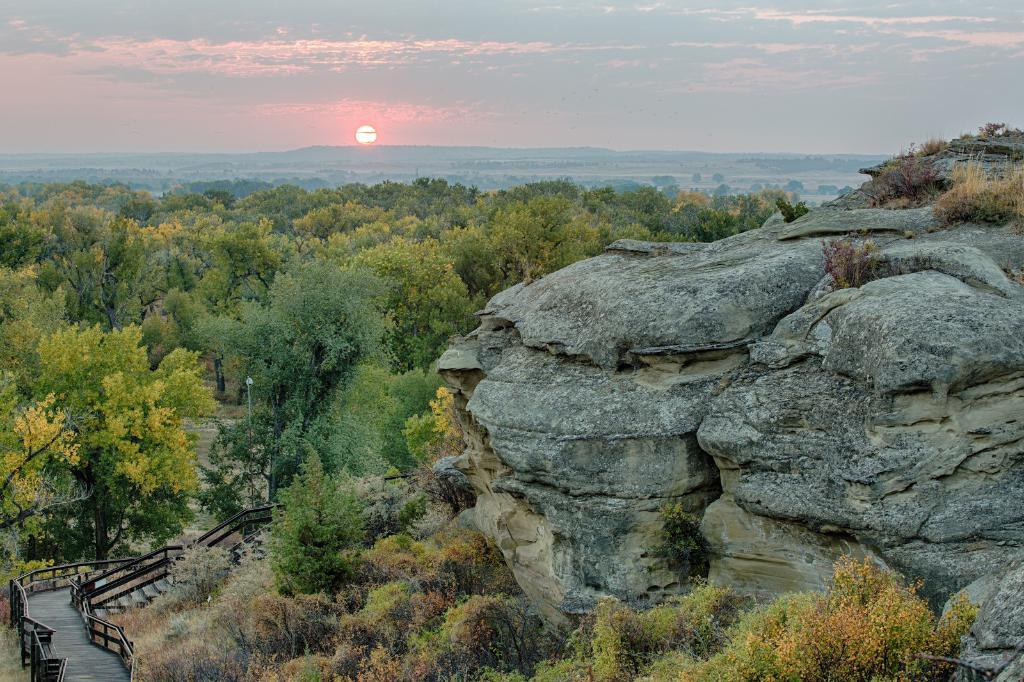What type of vegetation can be seen in the image? There are trees in the image. What geographical feature is located on the right side of the image? There is a mountain on the right side of the image. What natural phenomenon is visible in the background of the image? There is a beautiful sunrise visible in the background of the image. How many cannons are hidden among the trees in the image? There are no cannons present in the image; it features trees, a mountain, and a sunrise. What type of shellfish can be seen near the mountain in the image? There are no shellfish, such as clams, present in the image; it features trees, a mountain, and a sunrise. 